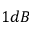<formula> <loc_0><loc_0><loc_500><loc_500>1 d B</formula> 